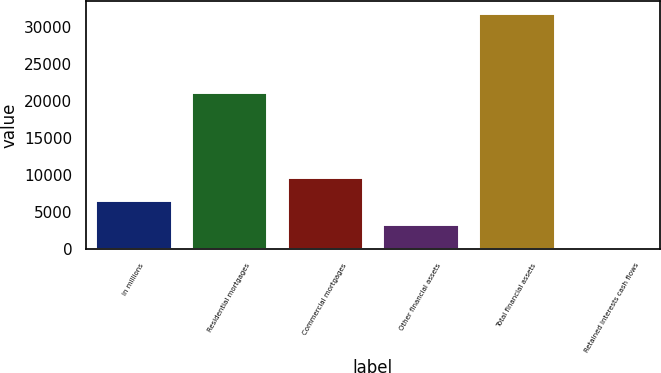<chart> <loc_0><loc_0><loc_500><loc_500><bar_chart><fcel>in millions<fcel>Residential mortgages<fcel>Commercial mortgages<fcel>Other financial assets<fcel>Total financial assets<fcel>Retained interests cash flows<nl><fcel>6614.4<fcel>21229<fcel>9773.6<fcel>3455.2<fcel>31888<fcel>296<nl></chart> 